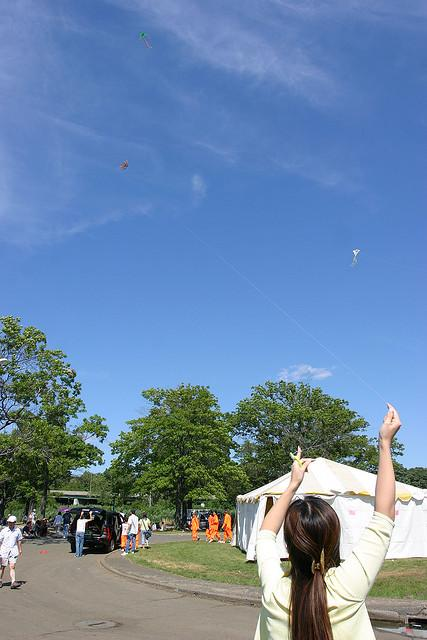What makes this a good day for flying kites? wind 